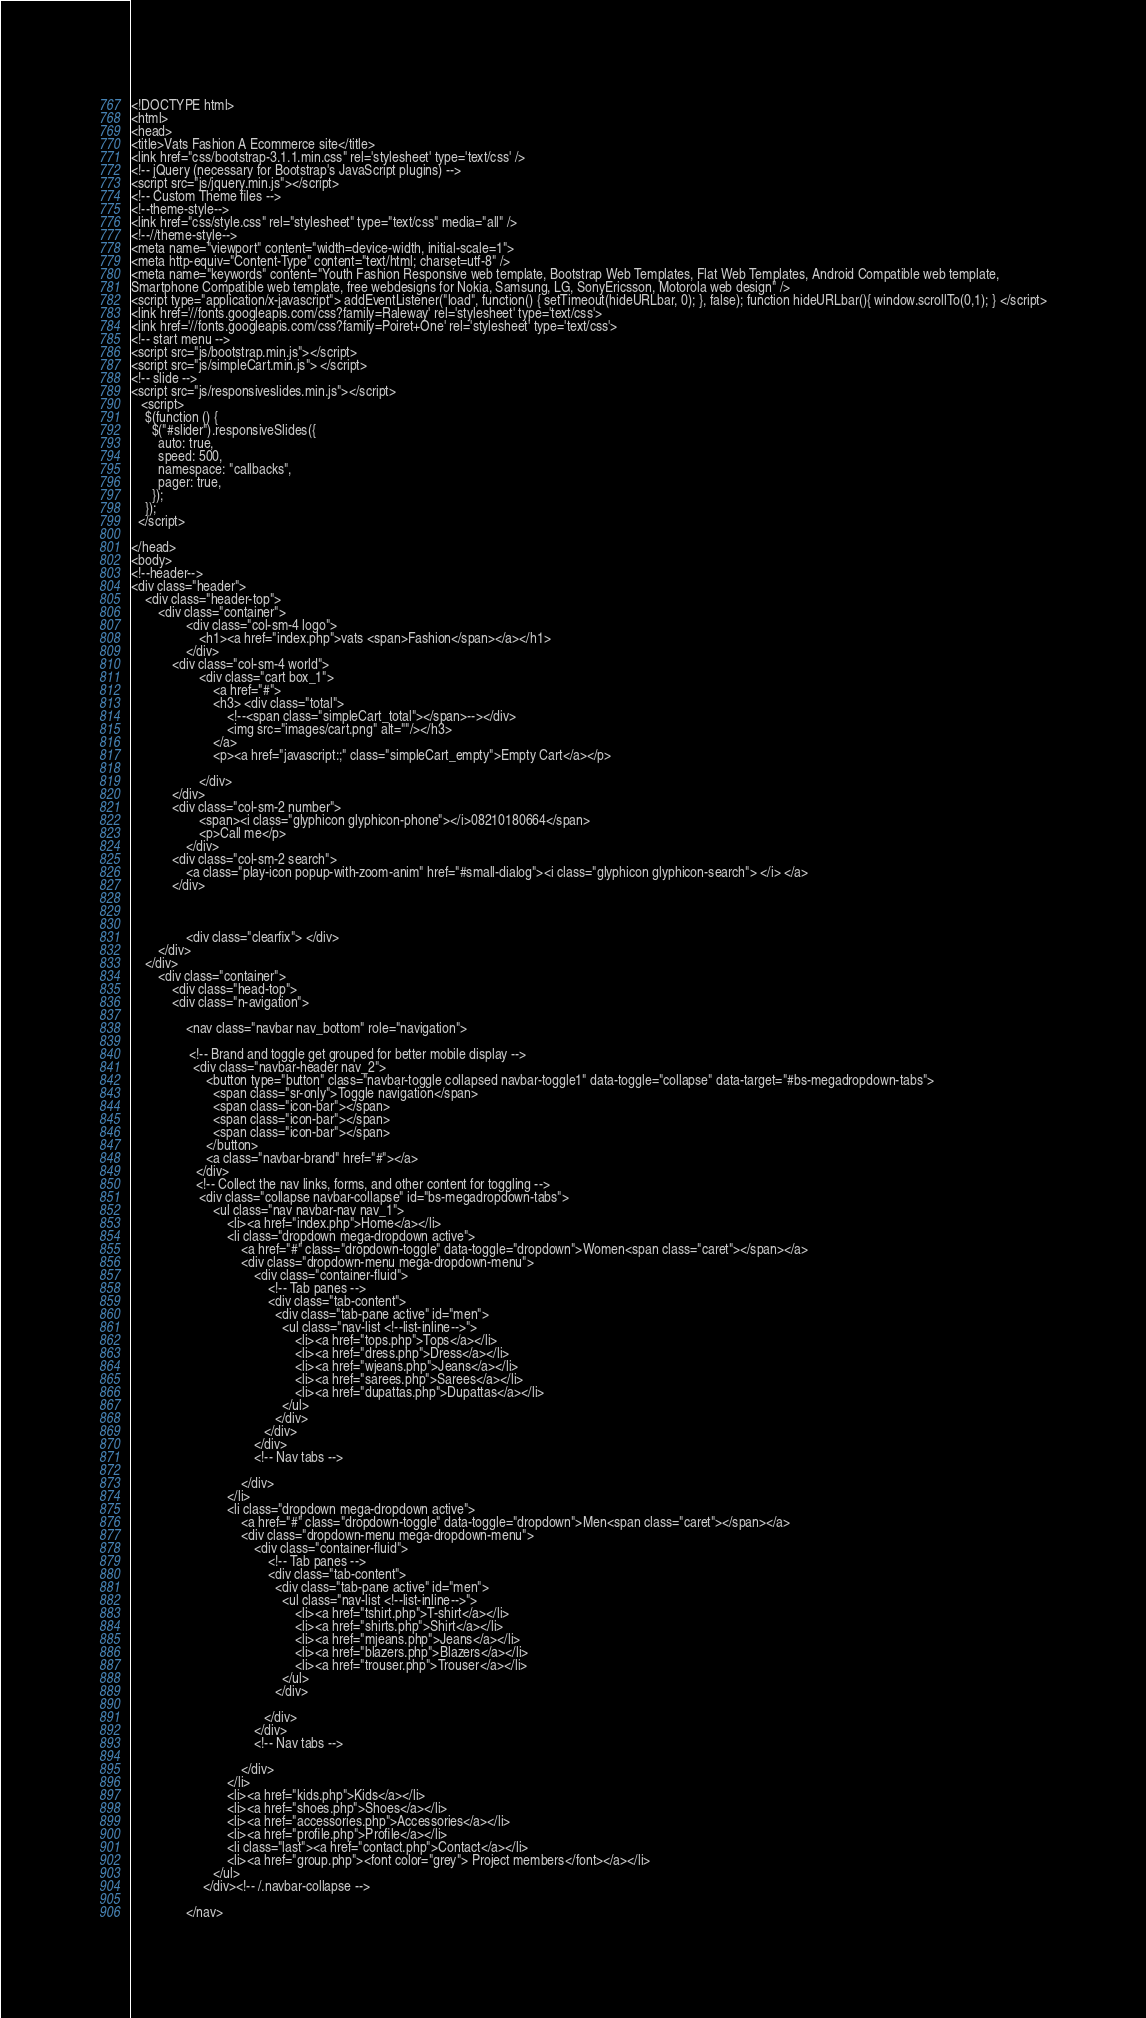<code> <loc_0><loc_0><loc_500><loc_500><_PHP_>
<!DOCTYPE html>
<html>
<head>
<title>Vats Fashion A Ecommerce site</title>
<link href="css/bootstrap-3.1.1.min.css" rel='stylesheet' type='text/css' />
<!-- jQuery (necessary for Bootstrap's JavaScript plugins) -->
<script src="js/jquery.min.js"></script>
<!-- Custom Theme files -->
<!--theme-style-->
<link href="css/style.css" rel="stylesheet" type="text/css" media="all" />	
<!--//theme-style-->
<meta name="viewport" content="width=device-width, initial-scale=1">
<meta http-equiv="Content-Type" content="text/html; charset=utf-8" />
<meta name="keywords" content="Youth Fashion Responsive web template, Bootstrap Web Templates, Flat Web Templates, Android Compatible web template, 
Smartphone Compatible web template, free webdesigns for Nokia, Samsung, LG, SonyEricsson, Motorola web design" />
<script type="application/x-javascript"> addEventListener("load", function() { setTimeout(hideURLbar, 0); }, false); function hideURLbar(){ window.scrollTo(0,1); } </script>
<link href='//fonts.googleapis.com/css?family=Raleway' rel='stylesheet' type='text/css'>
<link href='//fonts.googleapis.com/css?family=Poiret+One' rel='stylesheet' type='text/css'>
<!-- start menu -->
<script src="js/bootstrap.min.js"></script>
<script src="js/simpleCart.min.js"> </script>
<!-- slide -->
<script src="js/responsiveslides.min.js"></script>
   <script>
    $(function () {
      $("#slider").responsiveSlides({
      	auto: true,
      	speed: 500,
        namespace: "callbacks",
        pager: true,
      });
    });
  </script>

</head>
<body>
<!--header-->
<div class="header">
	<div class="header-top">
		<div class="container">
				<div class="col-sm-4 logo">
					<h1><a href="index.php">vats <span>Fashion</span></a></h1>	
				</div>
			<div class="col-sm-4 world">
					<div class="cart box_1">
						<a href="#">
						<h3> <div class="total">
							<!--<span class="simpleCart_total"></span>--></div>
							<img src="images/cart.png" alt=""/></h3>
						</a>
						<p><a href="javascript:;" class="simpleCart_empty">Empty Cart</a></p>

					</div>
			</div>
			<div class="col-sm-2 number">
					<span><i class="glyphicon glyphicon-phone"></i>08210180664</span>
					<p>Call me</p>
				</div>
			<div class="col-sm-2 search">		
				<a class="play-icon popup-with-zoom-anim" href="#small-dialog"><i class="glyphicon glyphicon-search"> </i> </a>
			</div>
			
			
			 
				<div class="clearfix"> </div>
		</div>
	</div>
		<div class="container">
			<div class="head-top">
			<div class="n-avigation">
			
				<nav class="navbar nav_bottom" role="navigation">
				
				 <!-- Brand and toggle get grouped for better mobile display -->
				  <div class="navbar-header nav_2">
					  <button type="button" class="navbar-toggle collapsed navbar-toggle1" data-toggle="collapse" data-target="#bs-megadropdown-tabs">
						<span class="sr-only">Toggle navigation</span>
						<span class="icon-bar"></span>
						<span class="icon-bar"></span>
						<span class="icon-bar"></span>
					  </button>
					  <a class="navbar-brand" href="#"></a>
				   </div> 
				   <!-- Collect the nav links, forms, and other content for toggling -->
					<div class="collapse navbar-collapse" id="bs-megadropdown-tabs">
						<ul class="nav navbar-nav nav_1">
							<li><a href="index.php">Home</a></li>
							<li class="dropdown mega-dropdown active">
								<a href="#" class="dropdown-toggle" data-toggle="dropdown">Women<span class="caret"></span></a>				
								<div class="dropdown-menu mega-dropdown-menu">
									<div class="container-fluid">
										<!-- Tab panes -->
										<div class="tab-content">
										  <div class="tab-pane active" id="men">
											<ul class="nav-list <!--list-inline-->">
												<li><a href="tops.php">Tops</a></li>
												<li><a href="dress.php">Dress</a></li>
												<li><a href="wjeans.php">Jeans</a></li>
												<li><a href="sarees.php">Sarees</a></li>
												<li><a href="dupattas.php">Dupattas</a></li>
											</ul>
										  </div>
									   </div>
									</div>
									<!-- Nav tabs -->
									                
								</div>				
							</li>
							<li class="dropdown mega-dropdown active">
								<a href="#" class="dropdown-toggle" data-toggle="dropdown">Men<span class="caret"></span></a>				
								<div class="dropdown-menu mega-dropdown-menu">
									<div class="container-fluid">
										<!-- Tab panes -->
										<div class="tab-content">
										  <div class="tab-pane active" id="men">
											<ul class="nav-list <!--list-inline-->">
												<li><a href="tshirt.php">T-shirt</a></li>
												<li><a href="shirts.php">Shirt</a></li>
												<li><a href="mjeans.php">Jeans</a></li>
												<li><a href="blazers.php">Blazers</a></li>
												<li><a href="trouser.php">Trouser</a></li>
											</ul>				
										  </div>
										 
									   </div>
									</div>
									<!-- Nav tabs -->
									                   
								</div>				
							</li>
							<li><a href="kids.php">Kids</a></li>
							<li><a href="shoes.php">Shoes</a></li>
							<li><a href="accessories.php">Accessories</a></li>
							<li><a href="profile.php">Profile</a></li>
							<li class="last"><a href="contact.php">Contact</a></li>
							<li><a href="group.php"><font color="grey"> Project members</font></a></li>
						</ul>
					 </div><!-- /.navbar-collapse -->
				  
				</nav></code> 